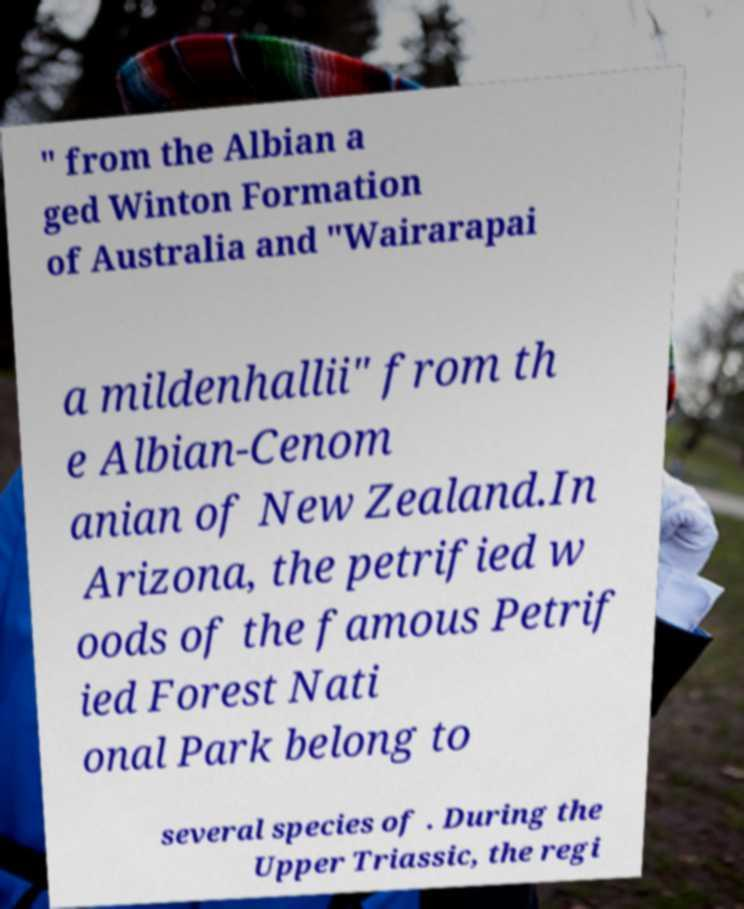Could you extract and type out the text from this image? " from the Albian a ged Winton Formation of Australia and "Wairarapai a mildenhallii" from th e Albian-Cenom anian of New Zealand.In Arizona, the petrified w oods of the famous Petrif ied Forest Nati onal Park belong to several species of . During the Upper Triassic, the regi 